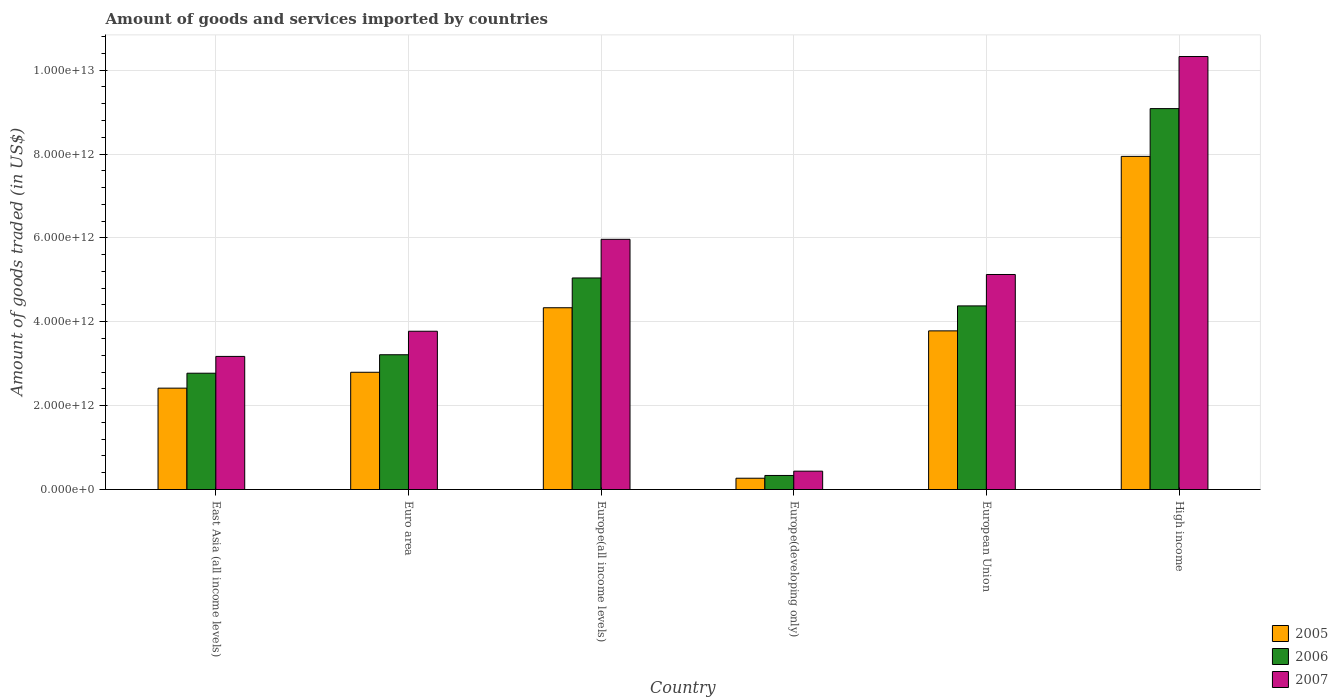How many different coloured bars are there?
Offer a very short reply. 3. How many bars are there on the 5th tick from the left?
Provide a succinct answer. 3. What is the label of the 5th group of bars from the left?
Your response must be concise. European Union. In how many cases, is the number of bars for a given country not equal to the number of legend labels?
Make the answer very short. 0. What is the total amount of goods and services imported in 2006 in Euro area?
Ensure brevity in your answer.  3.21e+12. Across all countries, what is the maximum total amount of goods and services imported in 2007?
Offer a very short reply. 1.03e+13. Across all countries, what is the minimum total amount of goods and services imported in 2006?
Your answer should be very brief. 3.35e+11. In which country was the total amount of goods and services imported in 2006 maximum?
Your answer should be very brief. High income. In which country was the total amount of goods and services imported in 2006 minimum?
Give a very brief answer. Europe(developing only). What is the total total amount of goods and services imported in 2006 in the graph?
Your answer should be very brief. 2.48e+13. What is the difference between the total amount of goods and services imported in 2007 in East Asia (all income levels) and that in European Union?
Your answer should be compact. -1.95e+12. What is the difference between the total amount of goods and services imported in 2006 in European Union and the total amount of goods and services imported in 2007 in Euro area?
Your answer should be compact. 6.04e+11. What is the average total amount of goods and services imported in 2006 per country?
Provide a succinct answer. 4.14e+12. What is the difference between the total amount of goods and services imported of/in 2006 and total amount of goods and services imported of/in 2007 in European Union?
Offer a very short reply. -7.49e+11. What is the ratio of the total amount of goods and services imported in 2005 in Europe(all income levels) to that in Europe(developing only)?
Offer a terse response. 16.09. Is the total amount of goods and services imported in 2007 in East Asia (all income levels) less than that in High income?
Provide a succinct answer. Yes. What is the difference between the highest and the second highest total amount of goods and services imported in 2007?
Offer a terse response. 4.36e+12. What is the difference between the highest and the lowest total amount of goods and services imported in 2005?
Your answer should be compact. 7.67e+12. Is the sum of the total amount of goods and services imported in 2007 in East Asia (all income levels) and Europe(developing only) greater than the maximum total amount of goods and services imported in 2005 across all countries?
Ensure brevity in your answer.  No. How many countries are there in the graph?
Provide a short and direct response. 6. What is the difference between two consecutive major ticks on the Y-axis?
Your answer should be very brief. 2.00e+12. Does the graph contain grids?
Offer a very short reply. Yes. Where does the legend appear in the graph?
Keep it short and to the point. Bottom right. How many legend labels are there?
Offer a terse response. 3. What is the title of the graph?
Ensure brevity in your answer.  Amount of goods and services imported by countries. Does "1990" appear as one of the legend labels in the graph?
Keep it short and to the point. No. What is the label or title of the Y-axis?
Provide a succinct answer. Amount of goods traded (in US$). What is the Amount of goods traded (in US$) of 2005 in East Asia (all income levels)?
Your answer should be very brief. 2.42e+12. What is the Amount of goods traded (in US$) in 2006 in East Asia (all income levels)?
Your answer should be very brief. 2.77e+12. What is the Amount of goods traded (in US$) of 2007 in East Asia (all income levels)?
Ensure brevity in your answer.  3.17e+12. What is the Amount of goods traded (in US$) of 2005 in Euro area?
Offer a terse response. 2.80e+12. What is the Amount of goods traded (in US$) in 2006 in Euro area?
Ensure brevity in your answer.  3.21e+12. What is the Amount of goods traded (in US$) of 2007 in Euro area?
Make the answer very short. 3.77e+12. What is the Amount of goods traded (in US$) of 2005 in Europe(all income levels)?
Offer a very short reply. 4.33e+12. What is the Amount of goods traded (in US$) in 2006 in Europe(all income levels)?
Offer a terse response. 5.04e+12. What is the Amount of goods traded (in US$) of 2007 in Europe(all income levels)?
Give a very brief answer. 5.97e+12. What is the Amount of goods traded (in US$) in 2005 in Europe(developing only)?
Give a very brief answer. 2.69e+11. What is the Amount of goods traded (in US$) of 2006 in Europe(developing only)?
Offer a very short reply. 3.35e+11. What is the Amount of goods traded (in US$) of 2007 in Europe(developing only)?
Your response must be concise. 4.38e+11. What is the Amount of goods traded (in US$) of 2005 in European Union?
Keep it short and to the point. 3.78e+12. What is the Amount of goods traded (in US$) in 2006 in European Union?
Your response must be concise. 4.38e+12. What is the Amount of goods traded (in US$) in 2007 in European Union?
Your answer should be compact. 5.13e+12. What is the Amount of goods traded (in US$) of 2005 in High income?
Give a very brief answer. 7.94e+12. What is the Amount of goods traded (in US$) of 2006 in High income?
Offer a terse response. 9.08e+12. What is the Amount of goods traded (in US$) in 2007 in High income?
Keep it short and to the point. 1.03e+13. Across all countries, what is the maximum Amount of goods traded (in US$) in 2005?
Your answer should be compact. 7.94e+12. Across all countries, what is the maximum Amount of goods traded (in US$) in 2006?
Offer a very short reply. 9.08e+12. Across all countries, what is the maximum Amount of goods traded (in US$) of 2007?
Provide a succinct answer. 1.03e+13. Across all countries, what is the minimum Amount of goods traded (in US$) in 2005?
Your answer should be very brief. 2.69e+11. Across all countries, what is the minimum Amount of goods traded (in US$) of 2006?
Offer a terse response. 3.35e+11. Across all countries, what is the minimum Amount of goods traded (in US$) in 2007?
Your answer should be very brief. 4.38e+11. What is the total Amount of goods traded (in US$) of 2005 in the graph?
Give a very brief answer. 2.15e+13. What is the total Amount of goods traded (in US$) of 2006 in the graph?
Provide a succinct answer. 2.48e+13. What is the total Amount of goods traded (in US$) of 2007 in the graph?
Offer a very short reply. 2.88e+13. What is the difference between the Amount of goods traded (in US$) in 2005 in East Asia (all income levels) and that in Euro area?
Ensure brevity in your answer.  -3.79e+11. What is the difference between the Amount of goods traded (in US$) of 2006 in East Asia (all income levels) and that in Euro area?
Your answer should be compact. -4.40e+11. What is the difference between the Amount of goods traded (in US$) of 2007 in East Asia (all income levels) and that in Euro area?
Keep it short and to the point. -6.00e+11. What is the difference between the Amount of goods traded (in US$) of 2005 in East Asia (all income levels) and that in Europe(all income levels)?
Offer a terse response. -1.92e+12. What is the difference between the Amount of goods traded (in US$) in 2006 in East Asia (all income levels) and that in Europe(all income levels)?
Provide a short and direct response. -2.27e+12. What is the difference between the Amount of goods traded (in US$) of 2007 in East Asia (all income levels) and that in Europe(all income levels)?
Your response must be concise. -2.79e+12. What is the difference between the Amount of goods traded (in US$) of 2005 in East Asia (all income levels) and that in Europe(developing only)?
Provide a short and direct response. 2.15e+12. What is the difference between the Amount of goods traded (in US$) in 2006 in East Asia (all income levels) and that in Europe(developing only)?
Give a very brief answer. 2.44e+12. What is the difference between the Amount of goods traded (in US$) of 2007 in East Asia (all income levels) and that in Europe(developing only)?
Offer a terse response. 2.74e+12. What is the difference between the Amount of goods traded (in US$) of 2005 in East Asia (all income levels) and that in European Union?
Offer a very short reply. -1.37e+12. What is the difference between the Amount of goods traded (in US$) in 2006 in East Asia (all income levels) and that in European Union?
Your response must be concise. -1.61e+12. What is the difference between the Amount of goods traded (in US$) in 2007 in East Asia (all income levels) and that in European Union?
Ensure brevity in your answer.  -1.95e+12. What is the difference between the Amount of goods traded (in US$) in 2005 in East Asia (all income levels) and that in High income?
Offer a very short reply. -5.53e+12. What is the difference between the Amount of goods traded (in US$) of 2006 in East Asia (all income levels) and that in High income?
Your answer should be very brief. -6.31e+12. What is the difference between the Amount of goods traded (in US$) in 2007 in East Asia (all income levels) and that in High income?
Your answer should be compact. -7.15e+12. What is the difference between the Amount of goods traded (in US$) of 2005 in Euro area and that in Europe(all income levels)?
Give a very brief answer. -1.54e+12. What is the difference between the Amount of goods traded (in US$) of 2006 in Euro area and that in Europe(all income levels)?
Give a very brief answer. -1.83e+12. What is the difference between the Amount of goods traded (in US$) in 2007 in Euro area and that in Europe(all income levels)?
Make the answer very short. -2.19e+12. What is the difference between the Amount of goods traded (in US$) in 2005 in Euro area and that in Europe(developing only)?
Your answer should be very brief. 2.53e+12. What is the difference between the Amount of goods traded (in US$) of 2006 in Euro area and that in Europe(developing only)?
Your answer should be compact. 2.88e+12. What is the difference between the Amount of goods traded (in US$) of 2007 in Euro area and that in Europe(developing only)?
Give a very brief answer. 3.34e+12. What is the difference between the Amount of goods traded (in US$) in 2005 in Euro area and that in European Union?
Make the answer very short. -9.88e+11. What is the difference between the Amount of goods traded (in US$) of 2006 in Euro area and that in European Union?
Ensure brevity in your answer.  -1.16e+12. What is the difference between the Amount of goods traded (in US$) in 2007 in Euro area and that in European Union?
Your answer should be very brief. -1.35e+12. What is the difference between the Amount of goods traded (in US$) of 2005 in Euro area and that in High income?
Provide a succinct answer. -5.15e+12. What is the difference between the Amount of goods traded (in US$) of 2006 in Euro area and that in High income?
Offer a terse response. -5.87e+12. What is the difference between the Amount of goods traded (in US$) of 2007 in Euro area and that in High income?
Your response must be concise. -6.55e+12. What is the difference between the Amount of goods traded (in US$) of 2005 in Europe(all income levels) and that in Europe(developing only)?
Your answer should be compact. 4.06e+12. What is the difference between the Amount of goods traded (in US$) in 2006 in Europe(all income levels) and that in Europe(developing only)?
Offer a very short reply. 4.71e+12. What is the difference between the Amount of goods traded (in US$) in 2007 in Europe(all income levels) and that in Europe(developing only)?
Your response must be concise. 5.53e+12. What is the difference between the Amount of goods traded (in US$) in 2005 in Europe(all income levels) and that in European Union?
Your response must be concise. 5.51e+11. What is the difference between the Amount of goods traded (in US$) of 2006 in Europe(all income levels) and that in European Union?
Provide a succinct answer. 6.66e+11. What is the difference between the Amount of goods traded (in US$) in 2007 in Europe(all income levels) and that in European Union?
Provide a short and direct response. 8.39e+11. What is the difference between the Amount of goods traded (in US$) in 2005 in Europe(all income levels) and that in High income?
Give a very brief answer. -3.61e+12. What is the difference between the Amount of goods traded (in US$) in 2006 in Europe(all income levels) and that in High income?
Ensure brevity in your answer.  -4.04e+12. What is the difference between the Amount of goods traded (in US$) of 2007 in Europe(all income levels) and that in High income?
Keep it short and to the point. -4.36e+12. What is the difference between the Amount of goods traded (in US$) in 2005 in Europe(developing only) and that in European Union?
Provide a short and direct response. -3.51e+12. What is the difference between the Amount of goods traded (in US$) of 2006 in Europe(developing only) and that in European Union?
Make the answer very short. -4.04e+12. What is the difference between the Amount of goods traded (in US$) in 2007 in Europe(developing only) and that in European Union?
Offer a very short reply. -4.69e+12. What is the difference between the Amount of goods traded (in US$) in 2005 in Europe(developing only) and that in High income?
Provide a succinct answer. -7.67e+12. What is the difference between the Amount of goods traded (in US$) in 2006 in Europe(developing only) and that in High income?
Your response must be concise. -8.75e+12. What is the difference between the Amount of goods traded (in US$) of 2007 in Europe(developing only) and that in High income?
Ensure brevity in your answer.  -9.89e+12. What is the difference between the Amount of goods traded (in US$) in 2005 in European Union and that in High income?
Provide a succinct answer. -4.16e+12. What is the difference between the Amount of goods traded (in US$) in 2006 in European Union and that in High income?
Offer a terse response. -4.70e+12. What is the difference between the Amount of goods traded (in US$) of 2007 in European Union and that in High income?
Provide a short and direct response. -5.20e+12. What is the difference between the Amount of goods traded (in US$) in 2005 in East Asia (all income levels) and the Amount of goods traded (in US$) in 2006 in Euro area?
Provide a short and direct response. -7.96e+11. What is the difference between the Amount of goods traded (in US$) of 2005 in East Asia (all income levels) and the Amount of goods traded (in US$) of 2007 in Euro area?
Provide a short and direct response. -1.36e+12. What is the difference between the Amount of goods traded (in US$) in 2006 in East Asia (all income levels) and the Amount of goods traded (in US$) in 2007 in Euro area?
Provide a short and direct response. -1.00e+12. What is the difference between the Amount of goods traded (in US$) of 2005 in East Asia (all income levels) and the Amount of goods traded (in US$) of 2006 in Europe(all income levels)?
Provide a short and direct response. -2.63e+12. What is the difference between the Amount of goods traded (in US$) in 2005 in East Asia (all income levels) and the Amount of goods traded (in US$) in 2007 in Europe(all income levels)?
Your response must be concise. -3.55e+12. What is the difference between the Amount of goods traded (in US$) in 2006 in East Asia (all income levels) and the Amount of goods traded (in US$) in 2007 in Europe(all income levels)?
Your answer should be very brief. -3.19e+12. What is the difference between the Amount of goods traded (in US$) of 2005 in East Asia (all income levels) and the Amount of goods traded (in US$) of 2006 in Europe(developing only)?
Give a very brief answer. 2.08e+12. What is the difference between the Amount of goods traded (in US$) in 2005 in East Asia (all income levels) and the Amount of goods traded (in US$) in 2007 in Europe(developing only)?
Offer a very short reply. 1.98e+12. What is the difference between the Amount of goods traded (in US$) of 2006 in East Asia (all income levels) and the Amount of goods traded (in US$) of 2007 in Europe(developing only)?
Offer a very short reply. 2.34e+12. What is the difference between the Amount of goods traded (in US$) in 2005 in East Asia (all income levels) and the Amount of goods traded (in US$) in 2006 in European Union?
Offer a terse response. -1.96e+12. What is the difference between the Amount of goods traded (in US$) in 2005 in East Asia (all income levels) and the Amount of goods traded (in US$) in 2007 in European Union?
Your answer should be very brief. -2.71e+12. What is the difference between the Amount of goods traded (in US$) of 2006 in East Asia (all income levels) and the Amount of goods traded (in US$) of 2007 in European Union?
Give a very brief answer. -2.35e+12. What is the difference between the Amount of goods traded (in US$) of 2005 in East Asia (all income levels) and the Amount of goods traded (in US$) of 2006 in High income?
Provide a short and direct response. -6.67e+12. What is the difference between the Amount of goods traded (in US$) of 2005 in East Asia (all income levels) and the Amount of goods traded (in US$) of 2007 in High income?
Offer a very short reply. -7.91e+12. What is the difference between the Amount of goods traded (in US$) in 2006 in East Asia (all income levels) and the Amount of goods traded (in US$) in 2007 in High income?
Ensure brevity in your answer.  -7.55e+12. What is the difference between the Amount of goods traded (in US$) of 2005 in Euro area and the Amount of goods traded (in US$) of 2006 in Europe(all income levels)?
Provide a short and direct response. -2.25e+12. What is the difference between the Amount of goods traded (in US$) in 2005 in Euro area and the Amount of goods traded (in US$) in 2007 in Europe(all income levels)?
Provide a short and direct response. -3.17e+12. What is the difference between the Amount of goods traded (in US$) of 2006 in Euro area and the Amount of goods traded (in US$) of 2007 in Europe(all income levels)?
Keep it short and to the point. -2.75e+12. What is the difference between the Amount of goods traded (in US$) of 2005 in Euro area and the Amount of goods traded (in US$) of 2006 in Europe(developing only)?
Ensure brevity in your answer.  2.46e+12. What is the difference between the Amount of goods traded (in US$) of 2005 in Euro area and the Amount of goods traded (in US$) of 2007 in Europe(developing only)?
Provide a succinct answer. 2.36e+12. What is the difference between the Amount of goods traded (in US$) of 2006 in Euro area and the Amount of goods traded (in US$) of 2007 in Europe(developing only)?
Provide a short and direct response. 2.78e+12. What is the difference between the Amount of goods traded (in US$) of 2005 in Euro area and the Amount of goods traded (in US$) of 2006 in European Union?
Ensure brevity in your answer.  -1.58e+12. What is the difference between the Amount of goods traded (in US$) in 2005 in Euro area and the Amount of goods traded (in US$) in 2007 in European Union?
Your answer should be very brief. -2.33e+12. What is the difference between the Amount of goods traded (in US$) in 2006 in Euro area and the Amount of goods traded (in US$) in 2007 in European Union?
Your response must be concise. -1.91e+12. What is the difference between the Amount of goods traded (in US$) in 2005 in Euro area and the Amount of goods traded (in US$) in 2006 in High income?
Keep it short and to the point. -6.29e+12. What is the difference between the Amount of goods traded (in US$) in 2005 in Euro area and the Amount of goods traded (in US$) in 2007 in High income?
Ensure brevity in your answer.  -7.53e+12. What is the difference between the Amount of goods traded (in US$) of 2006 in Euro area and the Amount of goods traded (in US$) of 2007 in High income?
Make the answer very short. -7.11e+12. What is the difference between the Amount of goods traded (in US$) of 2005 in Europe(all income levels) and the Amount of goods traded (in US$) of 2006 in Europe(developing only)?
Make the answer very short. 4.00e+12. What is the difference between the Amount of goods traded (in US$) of 2005 in Europe(all income levels) and the Amount of goods traded (in US$) of 2007 in Europe(developing only)?
Keep it short and to the point. 3.90e+12. What is the difference between the Amount of goods traded (in US$) of 2006 in Europe(all income levels) and the Amount of goods traded (in US$) of 2007 in Europe(developing only)?
Provide a short and direct response. 4.61e+12. What is the difference between the Amount of goods traded (in US$) in 2005 in Europe(all income levels) and the Amount of goods traded (in US$) in 2006 in European Union?
Ensure brevity in your answer.  -4.41e+1. What is the difference between the Amount of goods traded (in US$) in 2005 in Europe(all income levels) and the Amount of goods traded (in US$) in 2007 in European Union?
Provide a short and direct response. -7.93e+11. What is the difference between the Amount of goods traded (in US$) of 2006 in Europe(all income levels) and the Amount of goods traded (in US$) of 2007 in European Union?
Make the answer very short. -8.29e+1. What is the difference between the Amount of goods traded (in US$) in 2005 in Europe(all income levels) and the Amount of goods traded (in US$) in 2006 in High income?
Your response must be concise. -4.75e+12. What is the difference between the Amount of goods traded (in US$) in 2005 in Europe(all income levels) and the Amount of goods traded (in US$) in 2007 in High income?
Keep it short and to the point. -5.99e+12. What is the difference between the Amount of goods traded (in US$) in 2006 in Europe(all income levels) and the Amount of goods traded (in US$) in 2007 in High income?
Give a very brief answer. -5.28e+12. What is the difference between the Amount of goods traded (in US$) of 2005 in Europe(developing only) and the Amount of goods traded (in US$) of 2006 in European Union?
Offer a very short reply. -4.11e+12. What is the difference between the Amount of goods traded (in US$) of 2005 in Europe(developing only) and the Amount of goods traded (in US$) of 2007 in European Union?
Provide a short and direct response. -4.86e+12. What is the difference between the Amount of goods traded (in US$) in 2006 in Europe(developing only) and the Amount of goods traded (in US$) in 2007 in European Union?
Your answer should be very brief. -4.79e+12. What is the difference between the Amount of goods traded (in US$) of 2005 in Europe(developing only) and the Amount of goods traded (in US$) of 2006 in High income?
Provide a succinct answer. -8.81e+12. What is the difference between the Amount of goods traded (in US$) in 2005 in Europe(developing only) and the Amount of goods traded (in US$) in 2007 in High income?
Provide a short and direct response. -1.01e+13. What is the difference between the Amount of goods traded (in US$) of 2006 in Europe(developing only) and the Amount of goods traded (in US$) of 2007 in High income?
Make the answer very short. -9.99e+12. What is the difference between the Amount of goods traded (in US$) in 2005 in European Union and the Amount of goods traded (in US$) in 2006 in High income?
Offer a very short reply. -5.30e+12. What is the difference between the Amount of goods traded (in US$) of 2005 in European Union and the Amount of goods traded (in US$) of 2007 in High income?
Make the answer very short. -6.54e+12. What is the difference between the Amount of goods traded (in US$) of 2006 in European Union and the Amount of goods traded (in US$) of 2007 in High income?
Provide a succinct answer. -5.95e+12. What is the average Amount of goods traded (in US$) of 2005 per country?
Keep it short and to the point. 3.59e+12. What is the average Amount of goods traded (in US$) in 2006 per country?
Make the answer very short. 4.14e+12. What is the average Amount of goods traded (in US$) of 2007 per country?
Provide a short and direct response. 4.80e+12. What is the difference between the Amount of goods traded (in US$) in 2005 and Amount of goods traded (in US$) in 2006 in East Asia (all income levels)?
Offer a terse response. -3.56e+11. What is the difference between the Amount of goods traded (in US$) in 2005 and Amount of goods traded (in US$) in 2007 in East Asia (all income levels)?
Offer a terse response. -7.57e+11. What is the difference between the Amount of goods traded (in US$) in 2006 and Amount of goods traded (in US$) in 2007 in East Asia (all income levels)?
Provide a short and direct response. -4.01e+11. What is the difference between the Amount of goods traded (in US$) of 2005 and Amount of goods traded (in US$) of 2006 in Euro area?
Offer a very short reply. -4.18e+11. What is the difference between the Amount of goods traded (in US$) in 2005 and Amount of goods traded (in US$) in 2007 in Euro area?
Your answer should be very brief. -9.78e+11. What is the difference between the Amount of goods traded (in US$) of 2006 and Amount of goods traded (in US$) of 2007 in Euro area?
Give a very brief answer. -5.60e+11. What is the difference between the Amount of goods traded (in US$) in 2005 and Amount of goods traded (in US$) in 2006 in Europe(all income levels)?
Offer a very short reply. -7.10e+11. What is the difference between the Amount of goods traded (in US$) in 2005 and Amount of goods traded (in US$) in 2007 in Europe(all income levels)?
Your response must be concise. -1.63e+12. What is the difference between the Amount of goods traded (in US$) in 2006 and Amount of goods traded (in US$) in 2007 in Europe(all income levels)?
Your answer should be compact. -9.22e+11. What is the difference between the Amount of goods traded (in US$) of 2005 and Amount of goods traded (in US$) of 2006 in Europe(developing only)?
Provide a succinct answer. -6.57e+1. What is the difference between the Amount of goods traded (in US$) in 2005 and Amount of goods traded (in US$) in 2007 in Europe(developing only)?
Give a very brief answer. -1.68e+11. What is the difference between the Amount of goods traded (in US$) in 2006 and Amount of goods traded (in US$) in 2007 in Europe(developing only)?
Keep it short and to the point. -1.03e+11. What is the difference between the Amount of goods traded (in US$) in 2005 and Amount of goods traded (in US$) in 2006 in European Union?
Your answer should be very brief. -5.95e+11. What is the difference between the Amount of goods traded (in US$) in 2005 and Amount of goods traded (in US$) in 2007 in European Union?
Your response must be concise. -1.34e+12. What is the difference between the Amount of goods traded (in US$) of 2006 and Amount of goods traded (in US$) of 2007 in European Union?
Ensure brevity in your answer.  -7.49e+11. What is the difference between the Amount of goods traded (in US$) in 2005 and Amount of goods traded (in US$) in 2006 in High income?
Your response must be concise. -1.14e+12. What is the difference between the Amount of goods traded (in US$) of 2005 and Amount of goods traded (in US$) of 2007 in High income?
Make the answer very short. -2.38e+12. What is the difference between the Amount of goods traded (in US$) of 2006 and Amount of goods traded (in US$) of 2007 in High income?
Make the answer very short. -1.24e+12. What is the ratio of the Amount of goods traded (in US$) of 2005 in East Asia (all income levels) to that in Euro area?
Make the answer very short. 0.86. What is the ratio of the Amount of goods traded (in US$) of 2006 in East Asia (all income levels) to that in Euro area?
Your answer should be compact. 0.86. What is the ratio of the Amount of goods traded (in US$) of 2007 in East Asia (all income levels) to that in Euro area?
Offer a very short reply. 0.84. What is the ratio of the Amount of goods traded (in US$) in 2005 in East Asia (all income levels) to that in Europe(all income levels)?
Keep it short and to the point. 0.56. What is the ratio of the Amount of goods traded (in US$) in 2006 in East Asia (all income levels) to that in Europe(all income levels)?
Keep it short and to the point. 0.55. What is the ratio of the Amount of goods traded (in US$) of 2007 in East Asia (all income levels) to that in Europe(all income levels)?
Offer a terse response. 0.53. What is the ratio of the Amount of goods traded (in US$) of 2005 in East Asia (all income levels) to that in Europe(developing only)?
Offer a terse response. 8.97. What is the ratio of the Amount of goods traded (in US$) of 2006 in East Asia (all income levels) to that in Europe(developing only)?
Ensure brevity in your answer.  8.28. What is the ratio of the Amount of goods traded (in US$) in 2007 in East Asia (all income levels) to that in Europe(developing only)?
Your response must be concise. 7.25. What is the ratio of the Amount of goods traded (in US$) in 2005 in East Asia (all income levels) to that in European Union?
Ensure brevity in your answer.  0.64. What is the ratio of the Amount of goods traded (in US$) in 2006 in East Asia (all income levels) to that in European Union?
Ensure brevity in your answer.  0.63. What is the ratio of the Amount of goods traded (in US$) in 2007 in East Asia (all income levels) to that in European Union?
Provide a short and direct response. 0.62. What is the ratio of the Amount of goods traded (in US$) of 2005 in East Asia (all income levels) to that in High income?
Offer a very short reply. 0.3. What is the ratio of the Amount of goods traded (in US$) in 2006 in East Asia (all income levels) to that in High income?
Your answer should be compact. 0.31. What is the ratio of the Amount of goods traded (in US$) of 2007 in East Asia (all income levels) to that in High income?
Make the answer very short. 0.31. What is the ratio of the Amount of goods traded (in US$) of 2005 in Euro area to that in Europe(all income levels)?
Give a very brief answer. 0.65. What is the ratio of the Amount of goods traded (in US$) of 2006 in Euro area to that in Europe(all income levels)?
Provide a succinct answer. 0.64. What is the ratio of the Amount of goods traded (in US$) in 2007 in Euro area to that in Europe(all income levels)?
Offer a terse response. 0.63. What is the ratio of the Amount of goods traded (in US$) of 2005 in Euro area to that in Europe(developing only)?
Give a very brief answer. 10.38. What is the ratio of the Amount of goods traded (in US$) of 2006 in Euro area to that in Europe(developing only)?
Offer a terse response. 9.59. What is the ratio of the Amount of goods traded (in US$) in 2007 in Euro area to that in Europe(developing only)?
Provide a short and direct response. 8.62. What is the ratio of the Amount of goods traded (in US$) of 2005 in Euro area to that in European Union?
Offer a terse response. 0.74. What is the ratio of the Amount of goods traded (in US$) in 2006 in Euro area to that in European Union?
Ensure brevity in your answer.  0.73. What is the ratio of the Amount of goods traded (in US$) in 2007 in Euro area to that in European Union?
Provide a short and direct response. 0.74. What is the ratio of the Amount of goods traded (in US$) in 2005 in Euro area to that in High income?
Ensure brevity in your answer.  0.35. What is the ratio of the Amount of goods traded (in US$) of 2006 in Euro area to that in High income?
Provide a short and direct response. 0.35. What is the ratio of the Amount of goods traded (in US$) in 2007 in Euro area to that in High income?
Keep it short and to the point. 0.37. What is the ratio of the Amount of goods traded (in US$) in 2005 in Europe(all income levels) to that in Europe(developing only)?
Keep it short and to the point. 16.09. What is the ratio of the Amount of goods traded (in US$) of 2006 in Europe(all income levels) to that in Europe(developing only)?
Make the answer very short. 15.05. What is the ratio of the Amount of goods traded (in US$) in 2007 in Europe(all income levels) to that in Europe(developing only)?
Provide a short and direct response. 13.63. What is the ratio of the Amount of goods traded (in US$) in 2005 in Europe(all income levels) to that in European Union?
Your answer should be compact. 1.15. What is the ratio of the Amount of goods traded (in US$) in 2006 in Europe(all income levels) to that in European Union?
Ensure brevity in your answer.  1.15. What is the ratio of the Amount of goods traded (in US$) of 2007 in Europe(all income levels) to that in European Union?
Keep it short and to the point. 1.16. What is the ratio of the Amount of goods traded (in US$) of 2005 in Europe(all income levels) to that in High income?
Your answer should be compact. 0.55. What is the ratio of the Amount of goods traded (in US$) in 2006 in Europe(all income levels) to that in High income?
Ensure brevity in your answer.  0.56. What is the ratio of the Amount of goods traded (in US$) of 2007 in Europe(all income levels) to that in High income?
Give a very brief answer. 0.58. What is the ratio of the Amount of goods traded (in US$) in 2005 in Europe(developing only) to that in European Union?
Keep it short and to the point. 0.07. What is the ratio of the Amount of goods traded (in US$) in 2006 in Europe(developing only) to that in European Union?
Your answer should be very brief. 0.08. What is the ratio of the Amount of goods traded (in US$) in 2007 in Europe(developing only) to that in European Union?
Your answer should be very brief. 0.09. What is the ratio of the Amount of goods traded (in US$) of 2005 in Europe(developing only) to that in High income?
Keep it short and to the point. 0.03. What is the ratio of the Amount of goods traded (in US$) in 2006 in Europe(developing only) to that in High income?
Make the answer very short. 0.04. What is the ratio of the Amount of goods traded (in US$) of 2007 in Europe(developing only) to that in High income?
Give a very brief answer. 0.04. What is the ratio of the Amount of goods traded (in US$) of 2005 in European Union to that in High income?
Offer a very short reply. 0.48. What is the ratio of the Amount of goods traded (in US$) in 2006 in European Union to that in High income?
Your response must be concise. 0.48. What is the ratio of the Amount of goods traded (in US$) of 2007 in European Union to that in High income?
Make the answer very short. 0.5. What is the difference between the highest and the second highest Amount of goods traded (in US$) of 2005?
Provide a succinct answer. 3.61e+12. What is the difference between the highest and the second highest Amount of goods traded (in US$) in 2006?
Your answer should be very brief. 4.04e+12. What is the difference between the highest and the second highest Amount of goods traded (in US$) of 2007?
Your response must be concise. 4.36e+12. What is the difference between the highest and the lowest Amount of goods traded (in US$) of 2005?
Your response must be concise. 7.67e+12. What is the difference between the highest and the lowest Amount of goods traded (in US$) in 2006?
Provide a succinct answer. 8.75e+12. What is the difference between the highest and the lowest Amount of goods traded (in US$) in 2007?
Provide a succinct answer. 9.89e+12. 